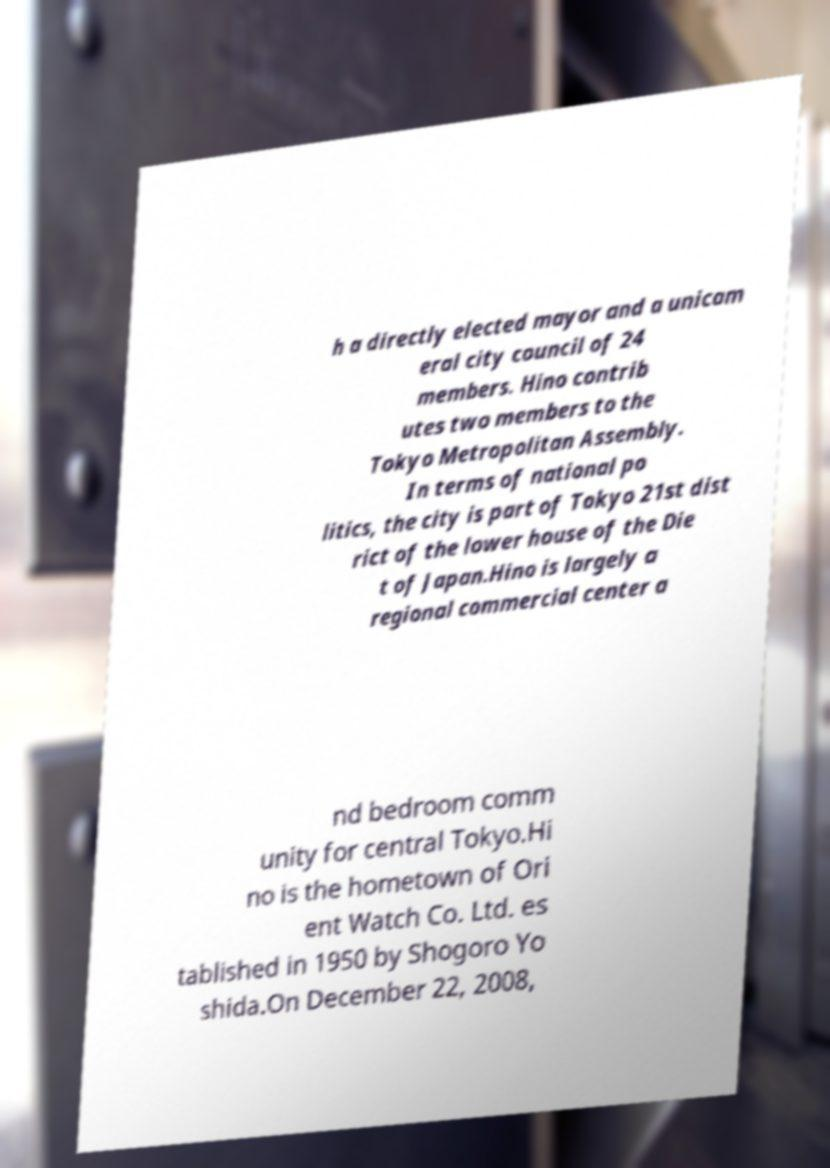Can you accurately transcribe the text from the provided image for me? h a directly elected mayor and a unicam eral city council of 24 members. Hino contrib utes two members to the Tokyo Metropolitan Assembly. In terms of national po litics, the city is part of Tokyo 21st dist rict of the lower house of the Die t of Japan.Hino is largely a regional commercial center a nd bedroom comm unity for central Tokyo.Hi no is the hometown of Ori ent Watch Co. Ltd. es tablished in 1950 by Shogoro Yo shida.On December 22, 2008, 